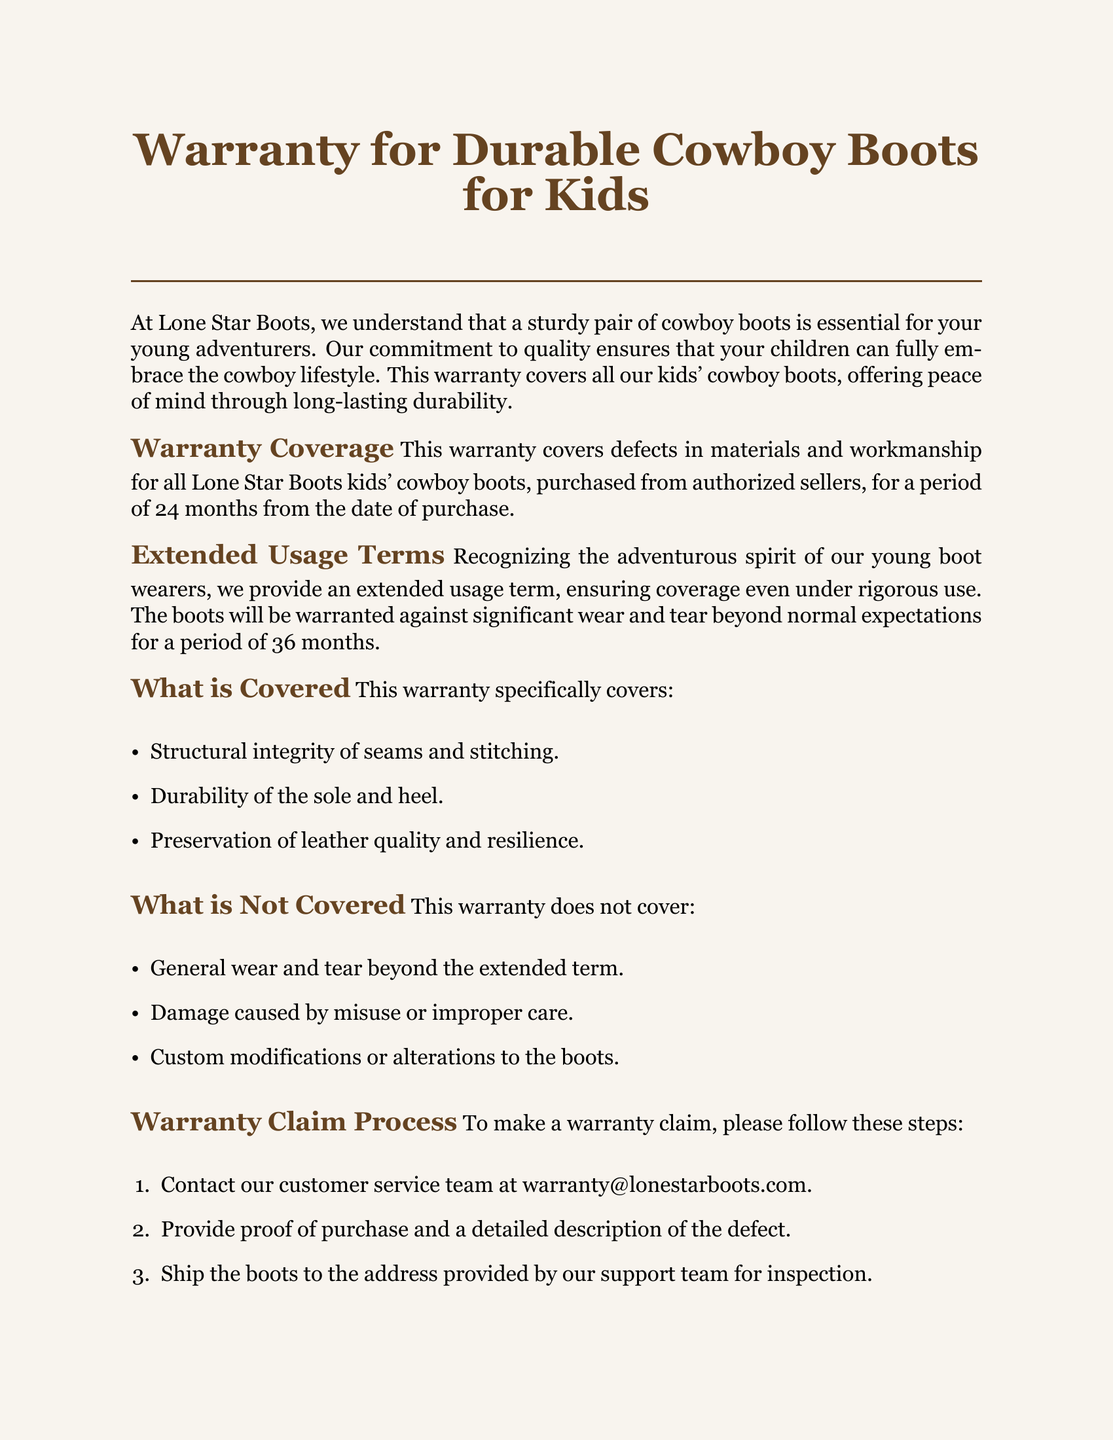What is the warranty period for defects in material and workmanship? The warranty period for defects in materials and workmanship is 24 months from the date of purchase.
Answer: 24 months What additional period does the warranty cover for significant wear and tear? The warranty provides an extended usage term against significant wear and tear for a period of 36 months.
Answer: 36 months What must be included when contacting customer service for a claim? Proof of purchase and a detailed description of the defect must be provided when contacting customer service for a claim.
Answer: Proof of purchase Which structural aspect of the boots is specifically covered by the warranty? The warranty covers the structural integrity of seams and stitching.
Answer: Seams and stitching What types of damage are explicitly not covered in the warranty? Damage caused by misuse or improper care is explicitly not covered in the warranty.
Answer: Misuse or improper care What is the contact email for warranty claims? The contact email for warranty claims is warranty@lonestarboots.com.
Answer: warranty@lonestarboots.com How can customers extend the life of their cowboy boots? Customers can visit the website for detailed care instructions and tips to extend the life of their cowboy boots.
Answer: Care instructions What is the phone number for additional support? The phone number for additional support is 1-800-LO-BOOTS.
Answer: 1-800-LO-BOOTS What type of products does this warranty cover? This warranty covers durable cowboy boots for kids.
Answer: Durable cowboy boots for kids 